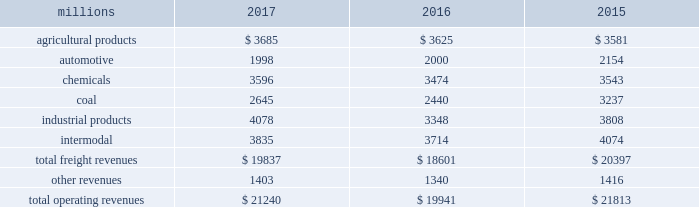Notes to the consolidated financial statements union pacific corporation and subsidiary companies for purposes of this report , unless the context otherwise requires , all references herein to the 201ccorporation 201d , 201ccompany 201d , 201cupc 201d , 201cwe 201d , 201cus 201d , and 201cour 201d mean union pacific corporation and its subsidiaries , including union pacific railroad company , which will be separately referred to herein as 201cuprr 201d or the 201crailroad 201d .
Nature of operations operations and segmentation 2013 we are a class i railroad operating in the u.s .
Our network includes 32122 route miles , linking pacific coast and gulf coast ports with the midwest and eastern u.s .
Gateways and providing several corridors to key mexican gateways .
We own 26042 miles and operate on the remainder pursuant to trackage rights or leases .
We serve the western two-thirds of the country and maintain coordinated schedules with other rail carriers for the handling of freight to and from the atlantic coast , the pacific coast , the southeast , the southwest , canada , and mexico .
Export and import traffic is moved through gulf coast and pacific coast ports and across the mexican and canadian borders .
The railroad , along with its subsidiaries and rail affiliates , is our one reportable operating segment .
Although we provide and analyze revenue by commodity group , we treat the financial results of the railroad as one segment due to the integrated nature of our rail network .
The table provides freight revenue by commodity group: .
Although our revenues are principally derived from customers domiciled in the u.s. , the ultimate points of origination or destination for some products we transport are outside the u.s .
Each of our commodity groups includes revenue from shipments to and from mexico .
Included in the above table are freight revenues from our mexico business which amounted to $ 2.3 billion in 2017 , $ 2.2 billion in 2016 , and $ 2.2 billion in 2015 .
Basis of presentation 2013 the consolidated financial statements are presented in accordance with accounting principles generally accepted in the u.s .
( gaap ) as codified in the financial accounting standards board ( fasb ) accounting standards codification ( asc ) .
Significant accounting policies principles of consolidation 2013 the consolidated financial statements include the accounts of union pacific corporation and all of its subsidiaries .
Investments in affiliated companies ( 20% ( 20 % ) to 50% ( 50 % ) owned ) are accounted for using the equity method of accounting .
All intercompany transactions are eliminated .
We currently have no less than majority-owned investments that require consolidation under variable interest entity requirements .
Cash and cash equivalents 2013 cash equivalents consist of investments with original maturities of three months or less .
Accounts receivable 2013 accounts receivable includes receivables reduced by an allowance for doubtful accounts .
The allowance is based upon historical losses , credit worthiness of customers , and current economic conditions .
Receivables not expected to be collected in one year and the associated allowances are classified as other assets in our consolidated statements of financial position. .
What is the percentage of the network route miles that is owned by the company? 
Computations: (26042 / 32122)
Answer: 0.81072. 